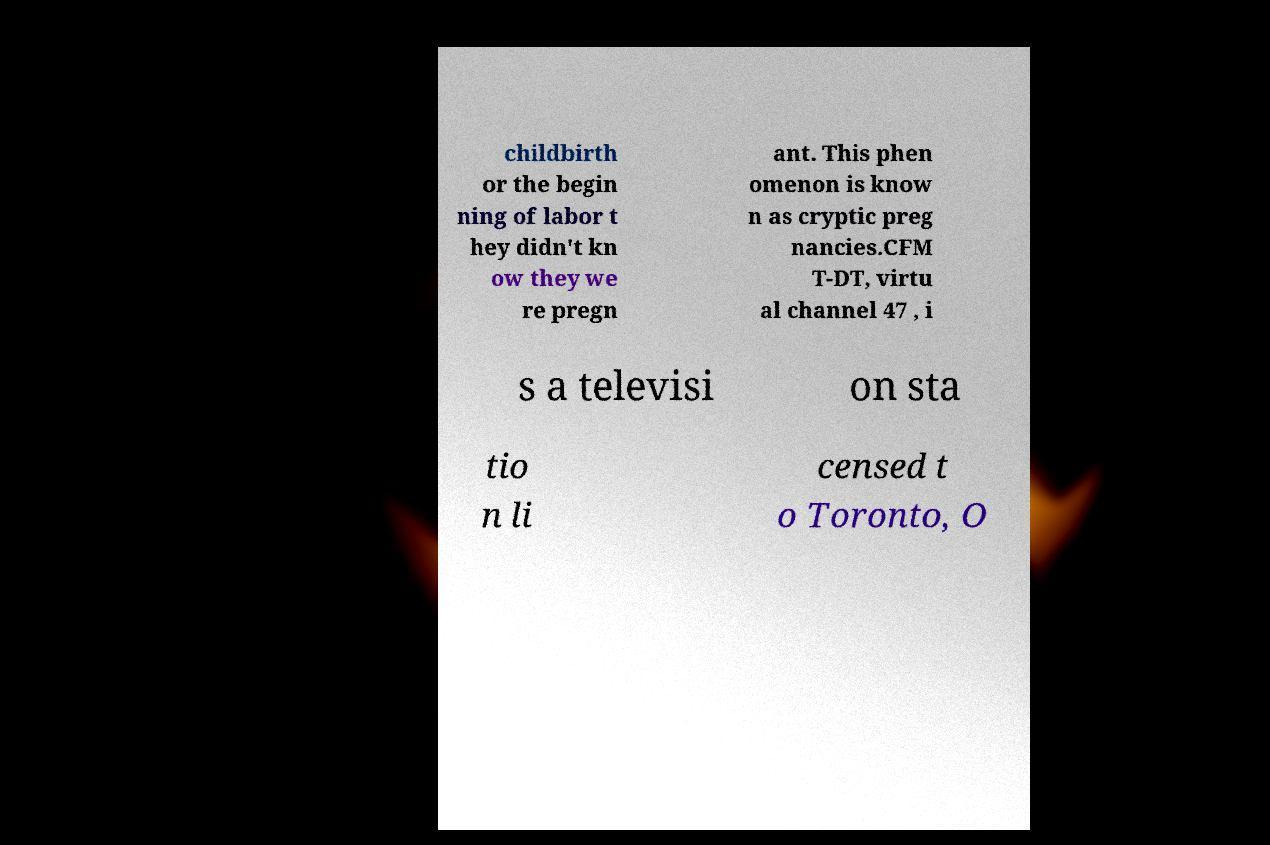Can you accurately transcribe the text from the provided image for me? childbirth or the begin ning of labor t hey didn't kn ow they we re pregn ant. This phen omenon is know n as cryptic preg nancies.CFM T-DT, virtu al channel 47 , i s a televisi on sta tio n li censed t o Toronto, O 